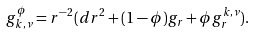Convert formula to latex. <formula><loc_0><loc_0><loc_500><loc_500>g _ { k , \nu } ^ { \phi } = r ^ { - 2 } ( d r ^ { 2 } + ( 1 - \phi ) g _ { r } + \phi g ^ { k , \nu } _ { r } ) .</formula> 